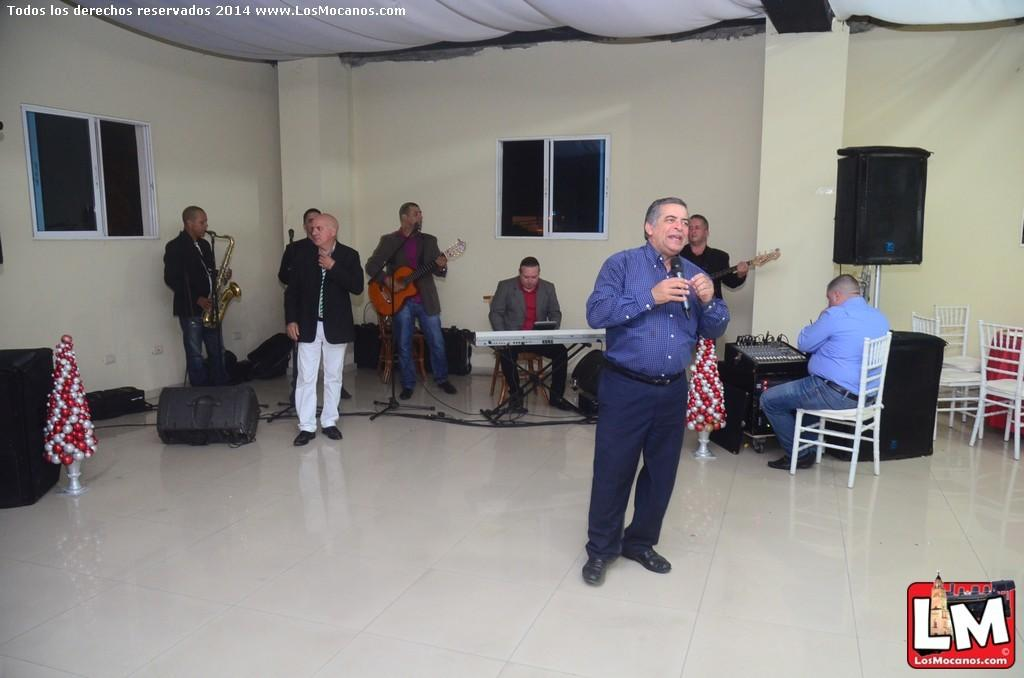How many people are in the image? There are multiple people in the image. What are the people in the image doing? The people are standing and holding musical instruments. Is there anyone sitting in the image? Yes, a man is sitting and playing a Casio. What type of trade is being conducted in the image? There is no trade being conducted in the image; it features people playing musical instruments. How many rays can be seen emanating from the man playing the Casio? There are no rays visible in the image; it is a group of people playing musical instruments. 